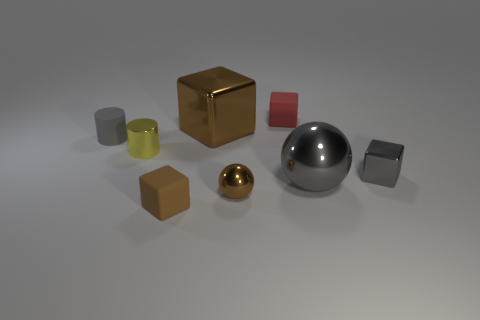Subtract all small gray blocks. How many blocks are left? 3 Subtract all blue spheres. How many brown blocks are left? 2 Subtract all gray blocks. How many blocks are left? 3 Add 2 tiny blue rubber cubes. How many objects exist? 10 Add 2 yellow objects. How many yellow objects are left? 3 Add 4 small purple blocks. How many small purple blocks exist? 4 Subtract 0 cyan cubes. How many objects are left? 8 Subtract all balls. How many objects are left? 6 Subtract all blue blocks. Subtract all blue spheres. How many blocks are left? 4 Subtract all small cyan blocks. Subtract all gray metal cubes. How many objects are left? 7 